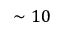<formula> <loc_0><loc_0><loc_500><loc_500>\sim 1 0</formula> 